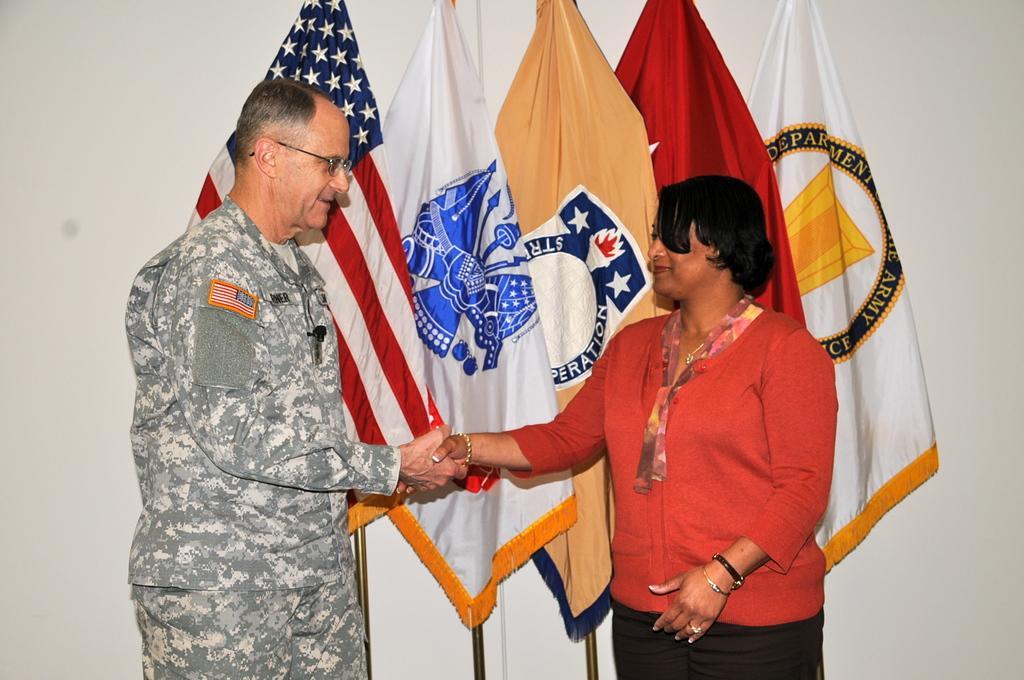In one or two sentences, can you explain what this image depicts? In this image I can see a person wearing military uniform and a woman wearing red and black colored dress are standing and shaking hands. In the background I can see the white colored wall and few flags. 